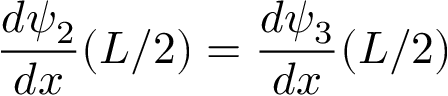<formula> <loc_0><loc_0><loc_500><loc_500>{ \frac { d \psi _ { 2 } } { d x } } ( L / 2 ) = { \frac { d \psi _ { 3 } } { d x } } ( L / 2 ) \,</formula> 